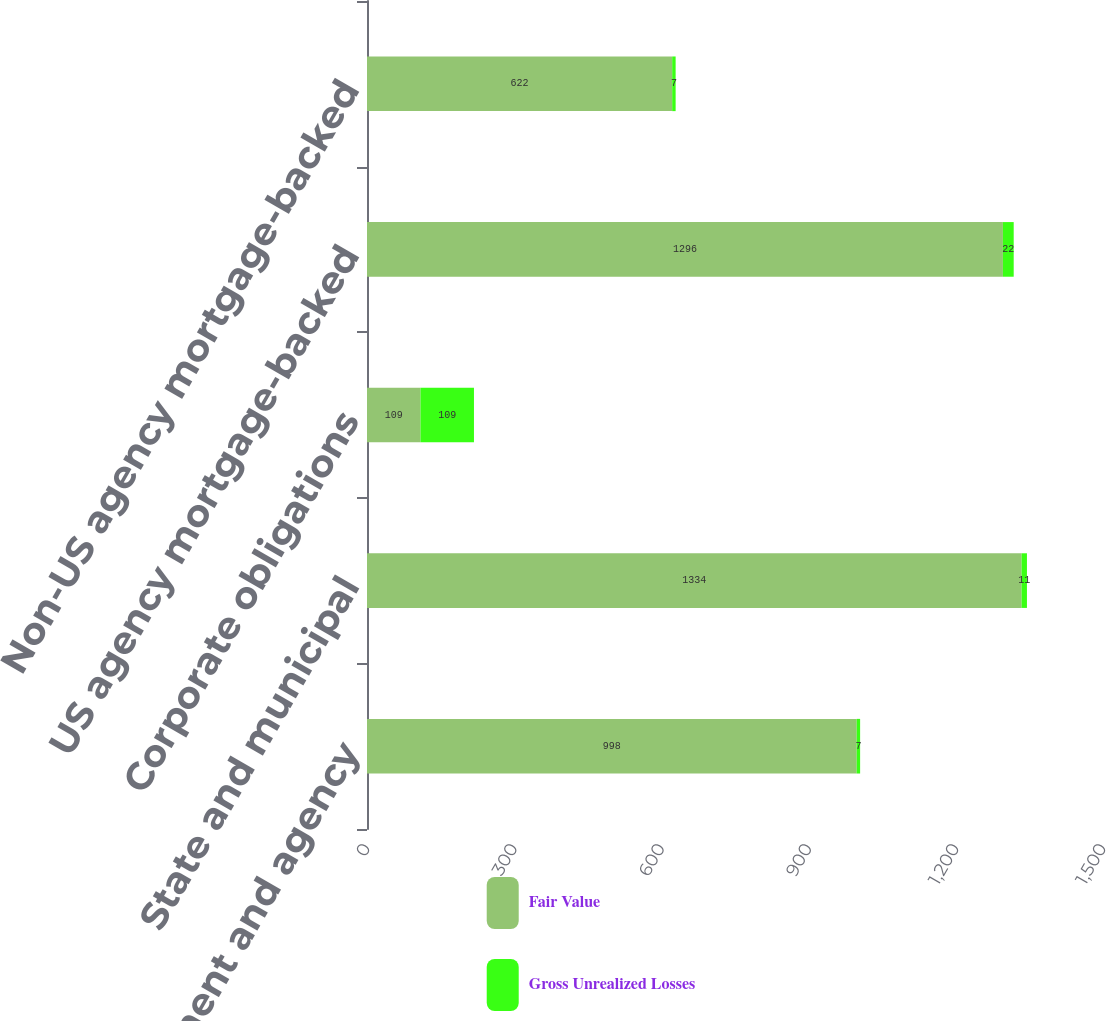Convert chart to OTSL. <chart><loc_0><loc_0><loc_500><loc_500><stacked_bar_chart><ecel><fcel>US government and agency<fcel>State and municipal<fcel>Corporate obligations<fcel>US agency mortgage-backed<fcel>Non-US agency mortgage-backed<nl><fcel>Fair Value<fcel>998<fcel>1334<fcel>109<fcel>1296<fcel>622<nl><fcel>Gross Unrealized Losses<fcel>7<fcel>11<fcel>109<fcel>22<fcel>7<nl></chart> 